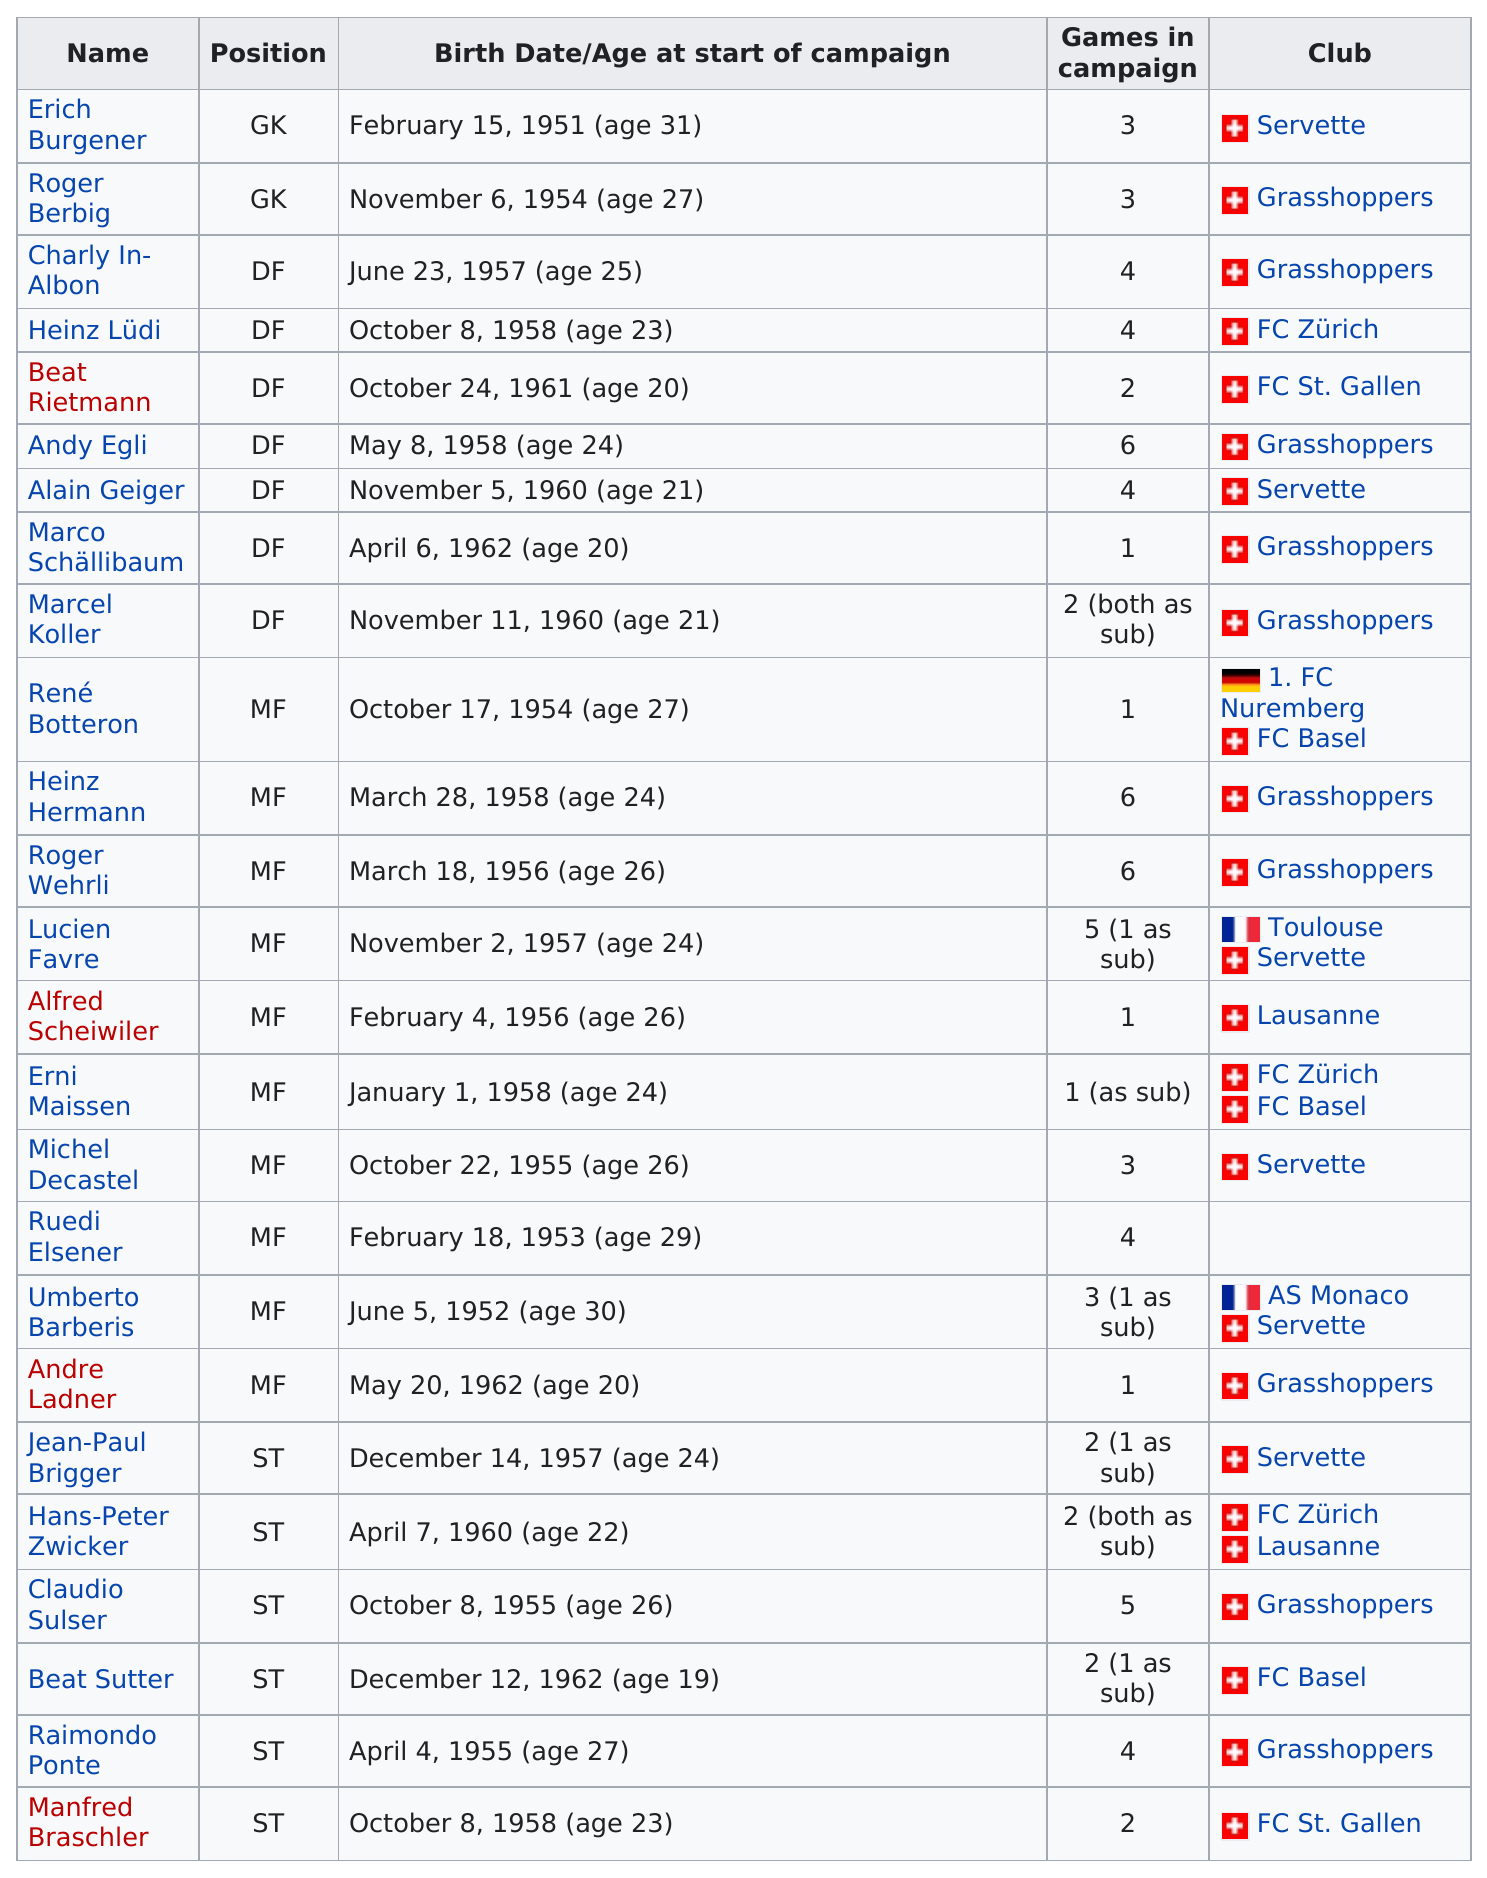Point out several critical features in this image. The average age of the grasshoppers was 24. The number of players that played for FC St. Gallen is 2. The club "Grasshopper" appears 10 times. Erich Burgener was the oldest player. It is stated that grasshoppers is listed as the club 10 times. 